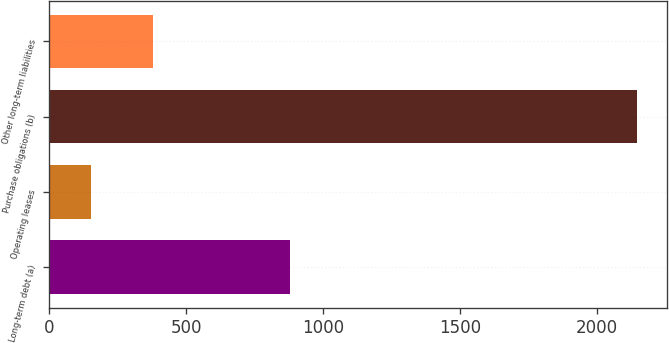Convert chart. <chart><loc_0><loc_0><loc_500><loc_500><bar_chart><fcel>Long-term debt (a)<fcel>Operating leases<fcel>Purchase obligations (b)<fcel>Other long-term liabilities<nl><fcel>881<fcel>152<fcel>2147<fcel>378<nl></chart> 